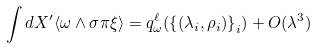Convert formula to latex. <formula><loc_0><loc_0><loc_500><loc_500>\int d { X ^ { \prime } } \langle \omega \wedge \sigma \pi \xi \rangle = q _ { \omega } ^ { \ell } ( \left \{ ( \lambda _ { i } , \rho _ { i } ) \right \} _ { i } ) + O ( \lambda ^ { 3 } )</formula> 